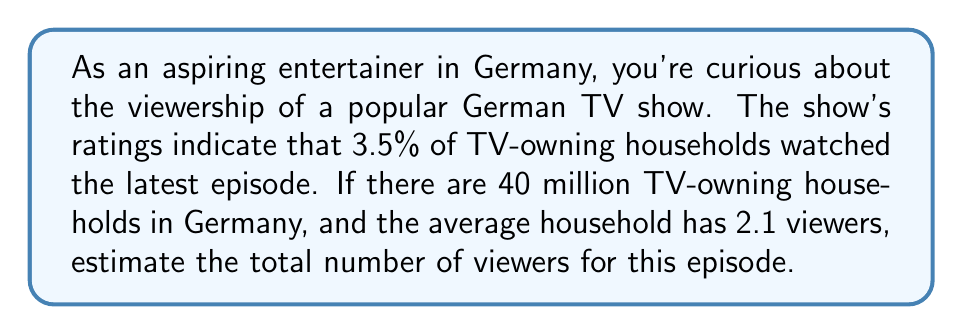Give your solution to this math problem. To solve this problem, we'll follow these steps:

1. Calculate the number of households that watched the show:
   Let $x$ be the number of households that watched the show.
   $$x = 3.5\% \times 40,000,000 = 0.035 \times 40,000,000 = 1,400,000$$

2. Calculate the total number of viewers:
   Let $y$ be the total number of viewers.
   $$y = x \times 2.1$$
   
   Substituting the value of $x$:
   $$y = 1,400,000 \times 2.1 = 2,940,000$$

Therefore, we estimate that 2,940,000 viewers watched this episode of the TV show.
Answer: $2,940,000$ viewers 